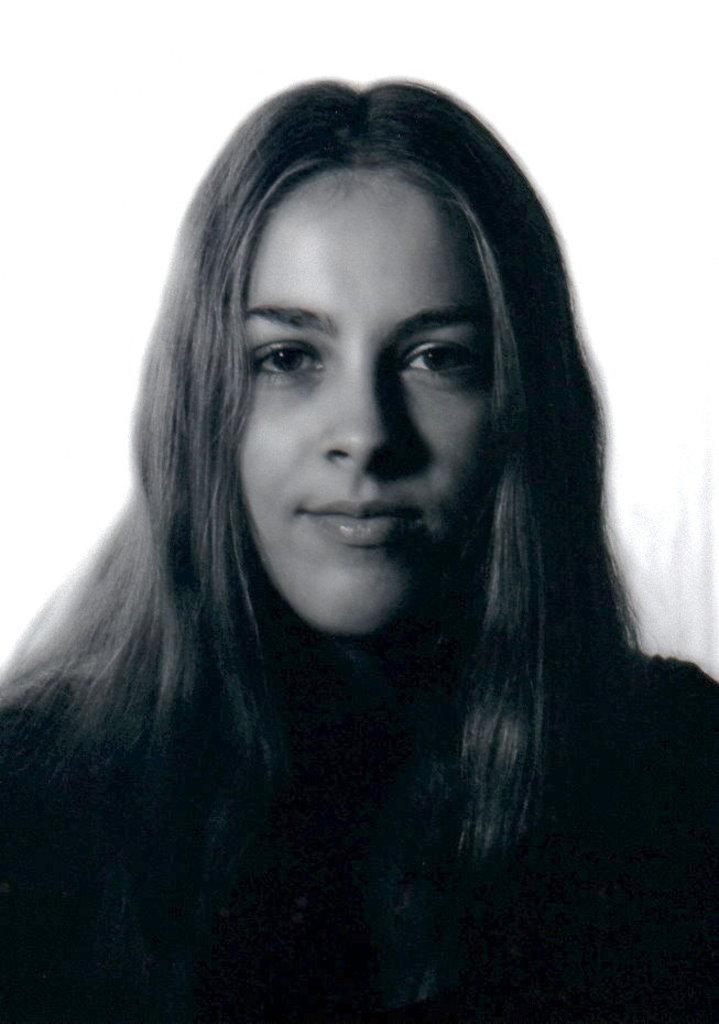What is the main subject of the image? There is a person in the image. What is the person wearing in the image? The person is wearing a dress. What is the color scheme of the image? The image is black and white. What type of hat is the person wearing in the image? There is no hat visible in the image; the person is wearing a dress. What type of plough can be seen in the background of the image? There is no plough present in the image; the image is focused on the person wearing a dress. 